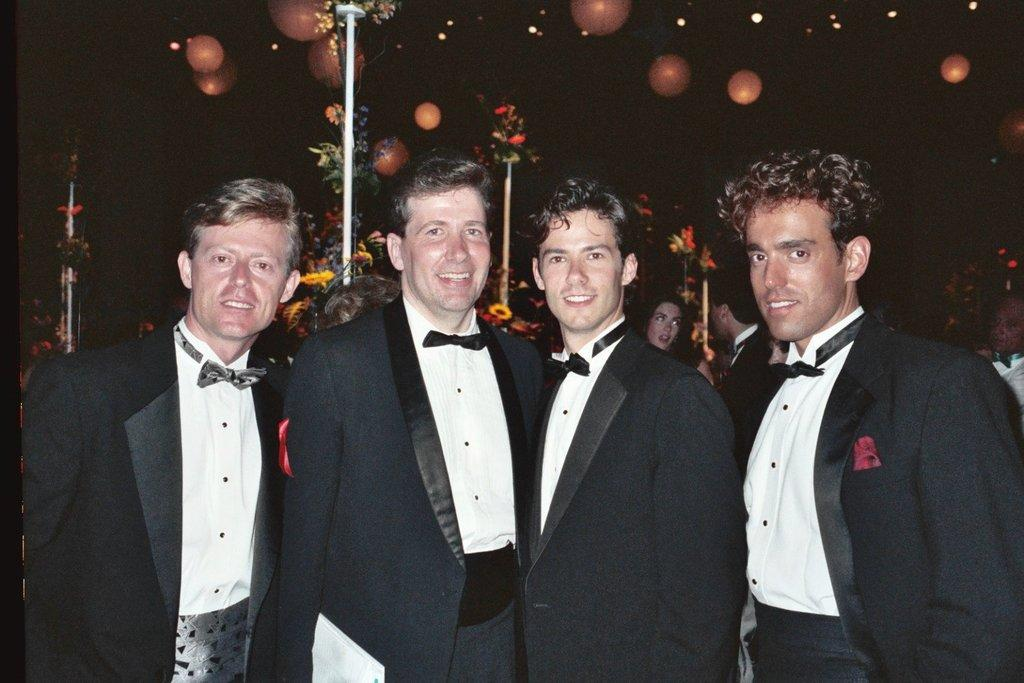How many men are in the image? There are four men in the image. What is happening behind the men? There are people behind the men. What decorative elements can be seen in the image? There are poles with flowers in the image. What can be used for illumination in the image? There are lights present in the image. What type of produce is being sold at the event in the image? There is no produce or event present in the image; it features four men, people, poles with flowers, and lights. 